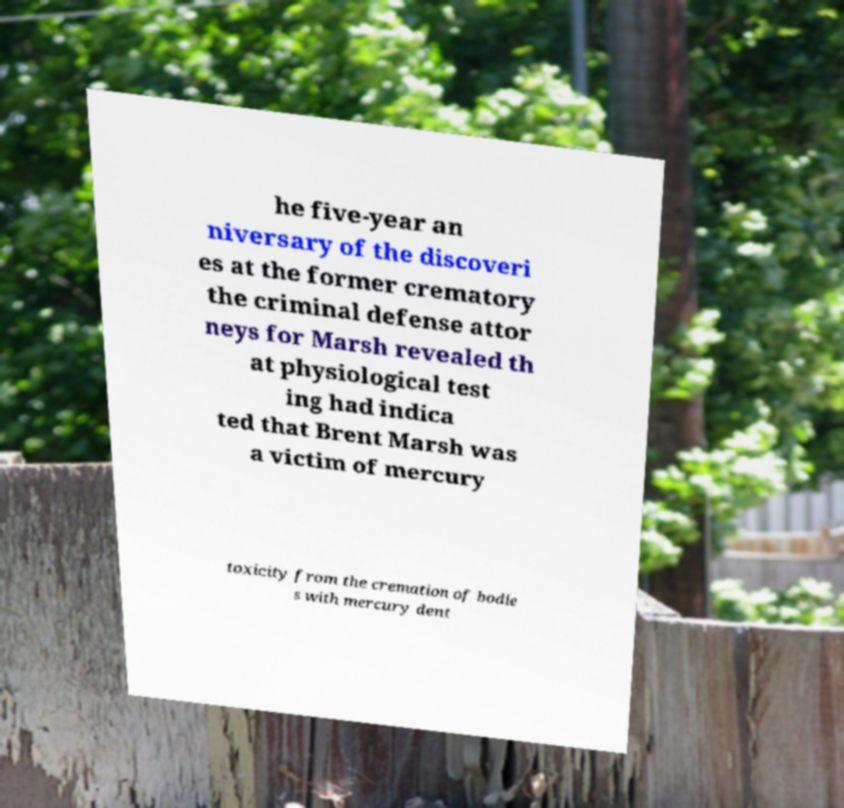For documentation purposes, I need the text within this image transcribed. Could you provide that? he five-year an niversary of the discoveri es at the former crematory the criminal defense attor neys for Marsh revealed th at physiological test ing had indica ted that Brent Marsh was a victim of mercury toxicity from the cremation of bodie s with mercury dent 